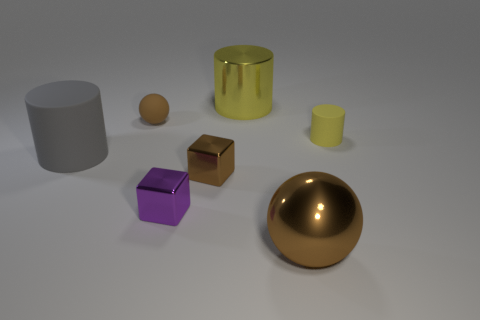Subtract all big metallic cylinders. How many cylinders are left? 2 Subtract all red spheres. How many yellow cylinders are left? 2 Subtract all gray cylinders. How many cylinders are left? 2 Subtract 1 cylinders. How many cylinders are left? 2 Add 3 purple matte things. How many objects exist? 10 Subtract all balls. How many objects are left? 5 Subtract all gray spheres. Subtract all green cylinders. How many spheres are left? 2 Subtract all big brown things. Subtract all large gray matte cylinders. How many objects are left? 5 Add 6 rubber objects. How many rubber objects are left? 9 Add 5 tiny gray rubber cylinders. How many tiny gray rubber cylinders exist? 5 